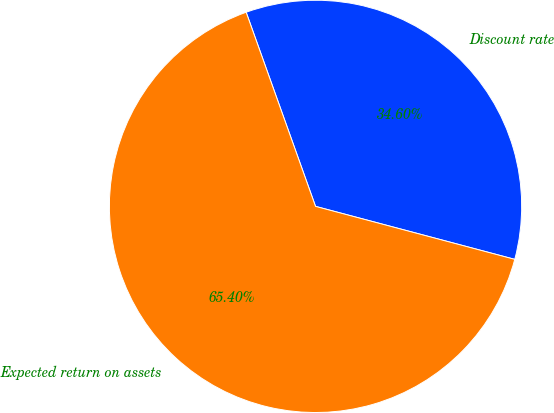Convert chart to OTSL. <chart><loc_0><loc_0><loc_500><loc_500><pie_chart><fcel>Discount rate<fcel>Expected return on assets<nl><fcel>34.6%<fcel>65.4%<nl></chart> 